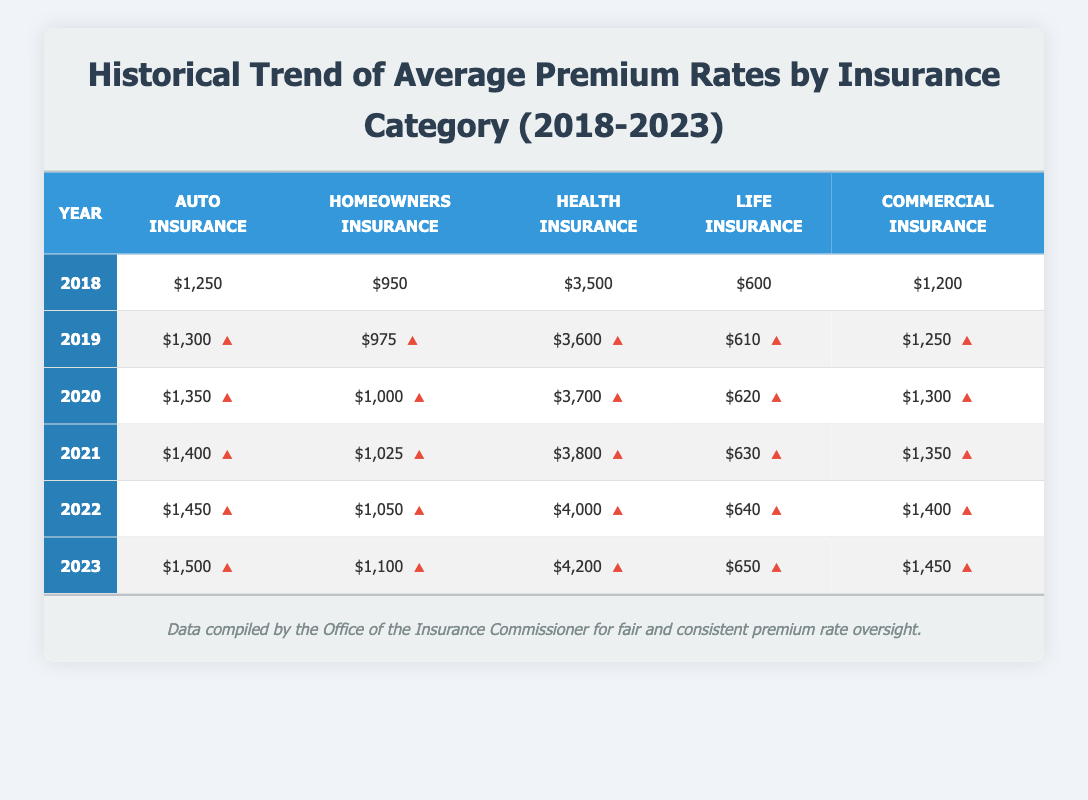What was the average premium rate for health insurance in 2021? The health insurance rate for 2021 is listed as 3800 in the table. Therefore, the average premium rate for health insurance in that year is 3800.
Answer: 3800 By how much did homeowners insurance premiums increase from 2018 to 2023? The homeowners insurance premium in 2018 was 950 and in 2023 it is 1100. The increase is calculated as 1100 - 950 = 150.
Answer: 150 Is the auto insurance premium rate higher in 2023 compared to 2020? The auto insurance premium for 2023 is 1500 and for 2020 it is 1350. Since 1500 is greater than 1350, the statement is true.
Answer: Yes What is the total premium rate for all types of insurance in 2022? To find the total for 2022, sum the individual premiums: 1450 (auto) + 1050 (homeowners) + 4000 (health) + 640 (life) + 1400 (commercial) =  1450 + 1050 + 4000 + 640 + 1400 =  8040.
Answer: 8040 Which category had the highest premium in 2019? In 2019, the premiums were: auto insurance 1300, homeowners insurance 975, health insurance 3600, life insurance 610, and commercial insurance 1250. The highest is 3600 for health insurance.
Answer: Health insurance How much more expensive was health insurance in 2023 compared to life insurance in the same year? In 2023, health insurance costs 4200 and life insurance costs 650. The difference is calculated as 4200 - 650 = 3550.
Answer: 3550 Did commercial insurance premiums ever decrease between 2018 and 2023? The commercial insurance premiums increased every year from 1200 in 2018 to 1450 in 2023. Therefore, there were no decreases during these years.
Answer: No What was the overall percentage increase in auto insurance premiums from 2018 to 2023? The auto insurance premium increased from 1250 in 2018 to 1500 in 2023. The percentage increase is calculated as ((1500 - 1250) / 1250) * 100 = 20%.
Answer: 20% 